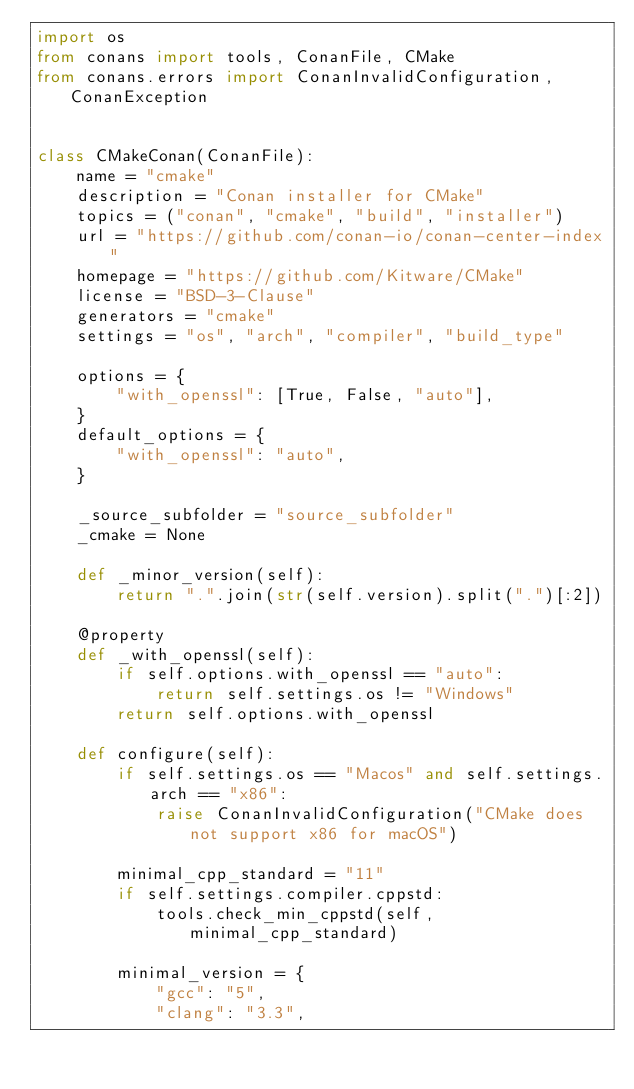<code> <loc_0><loc_0><loc_500><loc_500><_Python_>import os
from conans import tools, ConanFile, CMake
from conans.errors import ConanInvalidConfiguration, ConanException


class CMakeConan(ConanFile):
    name = "cmake"
    description = "Conan installer for CMake"
    topics = ("conan", "cmake", "build", "installer")
    url = "https://github.com/conan-io/conan-center-index"
    homepage = "https://github.com/Kitware/CMake"
    license = "BSD-3-Clause"
    generators = "cmake"
    settings = "os", "arch", "compiler", "build_type"

    options = {
        "with_openssl": [True, False, "auto"],
    }
    default_options = {
        "with_openssl": "auto",
    }

    _source_subfolder = "source_subfolder"
    _cmake = None

    def _minor_version(self):
        return ".".join(str(self.version).split(".")[:2])

    @property
    def _with_openssl(self):
        if self.options.with_openssl == "auto":
            return self.settings.os != "Windows"
        return self.options.with_openssl

    def configure(self):
        if self.settings.os == "Macos" and self.settings.arch == "x86":
            raise ConanInvalidConfiguration("CMake does not support x86 for macOS")

        minimal_cpp_standard = "11"
        if self.settings.compiler.cppstd:
            tools.check_min_cppstd(self, minimal_cpp_standard)

        minimal_version = {
            "gcc": "5",
            "clang": "3.3",</code> 